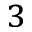<formula> <loc_0><loc_0><loc_500><loc_500>_ { 3 }</formula> 